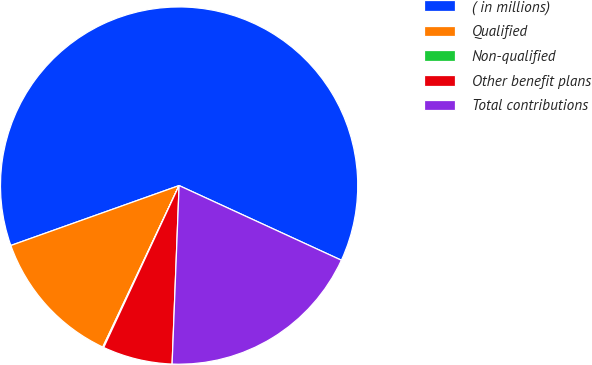Convert chart. <chart><loc_0><loc_0><loc_500><loc_500><pie_chart><fcel>( in millions)<fcel>Qualified<fcel>Non-qualified<fcel>Other benefit plans<fcel>Total contributions<nl><fcel>62.3%<fcel>12.53%<fcel>0.09%<fcel>6.31%<fcel>18.76%<nl></chart> 